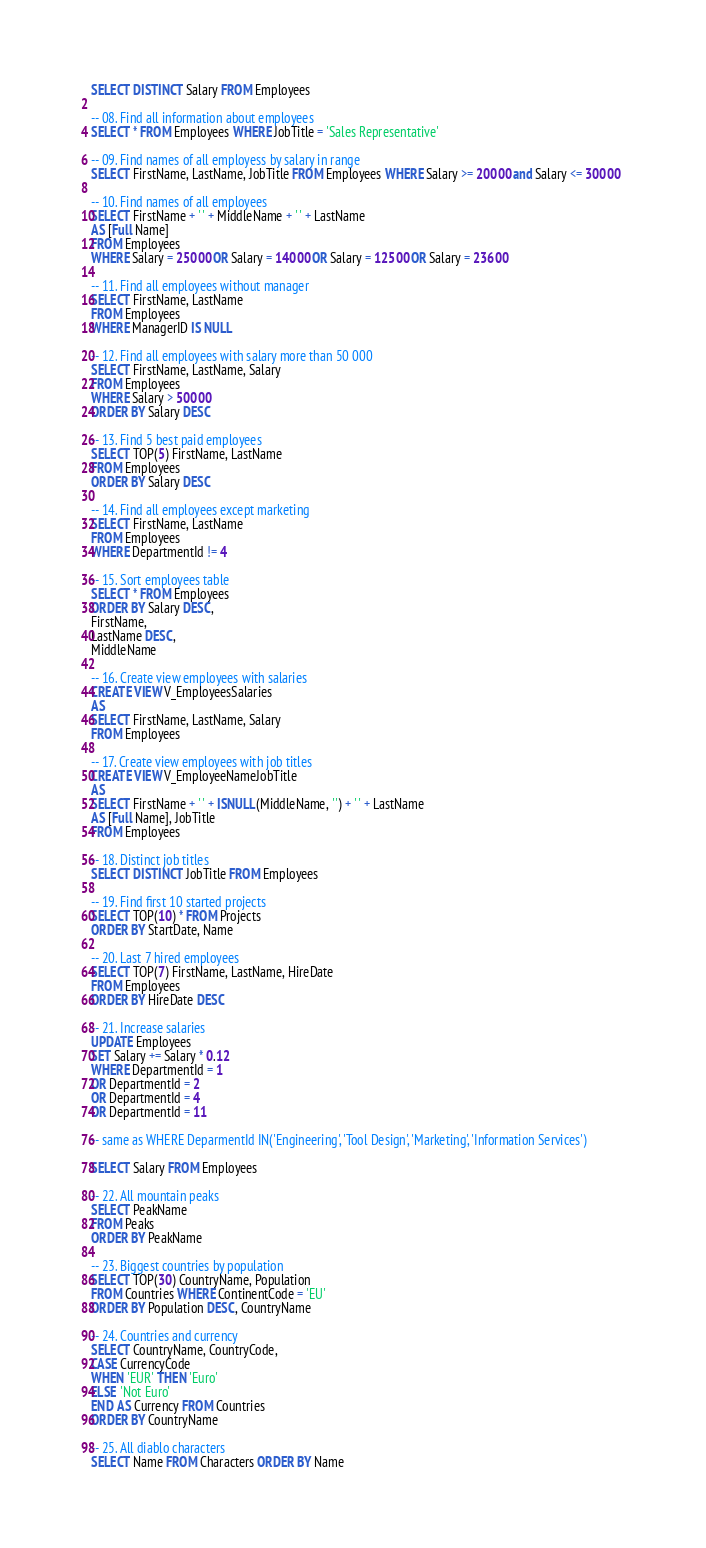<code> <loc_0><loc_0><loc_500><loc_500><_SQL_>SELECT DISTINCT Salary FROM Employees

-- 08. Find all information about employees
SELECT * FROM Employees WHERE JobTitle = 'Sales Representative'

-- 09. Find names of all employess by salary in range
SELECT FirstName, LastName, JobTitle FROM Employees WHERE Salary >= 20000 and Salary <= 30000  

-- 10. Find names of all employees
SELECT FirstName + ' ' + MiddleName + ' ' + LastName 
AS [Full Name] 
FROM Employees
WHERE Salary = 25000 OR Salary = 14000 OR Salary = 12500 OR Salary = 23600

-- 11. Find all employees without manager
SELECT FirstName, LastName 
FROM Employees
WHERE ManagerID IS NULL

-- 12. Find all employees with salary more than 50 000
SELECT FirstName, LastName, Salary 
FROM Employees
WHERE Salary > 50000
ORDER BY Salary DESC

-- 13. Find 5 best paid employees
SELECT TOP(5) FirstName, LastName 
FROM Employees
ORDER BY Salary DESC

-- 14. Find all employees except marketing
SELECT FirstName, LastName 
FROM Employees
WHERE DepartmentId != 4

-- 15. Sort employees table
SELECT * FROM Employees
ORDER BY Salary DESC, 
FirstName, 
LastName DESC, 
MiddleName

-- 16. Create view employees with salaries
CREATE VIEW V_EmployeesSalaries
AS
SELECT FirstName, LastName, Salary
FROM Employees

-- 17. Create view employees with job titles
CREATE VIEW V_EmployeeNameJobTitle 
AS
SELECT FirstName + ' ' + ISNULL(MiddleName, '') + ' ' + LastName 
AS [Full Name], JobTitle 
FROM Employees

-- 18. Distinct job titles
SELECT DISTINCT JobTitle FROM Employees

-- 19. Find first 10 started projects
SELECT TOP(10) * FROM Projects
ORDER BY StartDate, Name

-- 20. Last 7 hired employees
SELECT TOP(7) FirstName, LastName, HireDate
FROM Employees
ORDER BY HireDate DESC

-- 21. Increase salaries
UPDATE Employees
SET Salary += Salary * 0.12
WHERE DepartmentId = 1 
OR DepartmentId = 2 
OR DepartmentId = 4  
OR DepartmentId = 11

-- same as WHERE DeparmentId IN('Engineering', 'Tool Design', 'Marketing', 'Information Services')

SELECT Salary FROM Employees

-- 22. All mountain peaks
SELECT PeakName 
FROM Peaks
ORDER BY PeakName

-- 23. Biggest countries by population
SELECT TOP(30) CountryName, Population
FROM Countries WHERE ContinentCode = 'EU'
ORDER BY Population DESC, CountryName

-- 24. Countries and currency
SELECT CountryName, CountryCode, 
CASE CurrencyCode
WHEN 'EUR' THEN 'Euro'
ELSE 'Not Euro'
END AS Currency FROM Countries
ORDER BY CountryName

-- 25. All diablo characters
SELECT Name FROM Characters ORDER BY Name</code> 